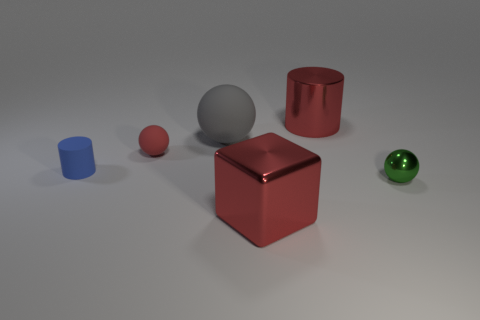There is a green object that is the same shape as the gray matte object; what material is it?
Your answer should be compact. Metal. Do the large cylinder and the red object that is to the left of the metallic block have the same material?
Provide a succinct answer. No. There is a thing that is on the right side of the big shiny thing behind the shiny sphere; what number of shiny balls are right of it?
Ensure brevity in your answer.  0. Is the number of blue things that are to the right of the small green metal sphere less than the number of small red spheres behind the large matte object?
Provide a short and direct response. No. How many other objects are the same material as the large gray object?
Keep it short and to the point. 2. There is a blue cylinder that is the same size as the green sphere; what is its material?
Offer a terse response. Rubber. How many green objects are either tiny metal objects or big metal cubes?
Your answer should be compact. 1. What color is the ball that is both in front of the large matte sphere and to the left of the red cylinder?
Ensure brevity in your answer.  Red. Is the cylinder behind the blue matte thing made of the same material as the large red thing in front of the red shiny cylinder?
Ensure brevity in your answer.  Yes. Is the number of tiny blue objects that are behind the tiny red thing greater than the number of rubber cylinders that are behind the large gray thing?
Give a very brief answer. No. 